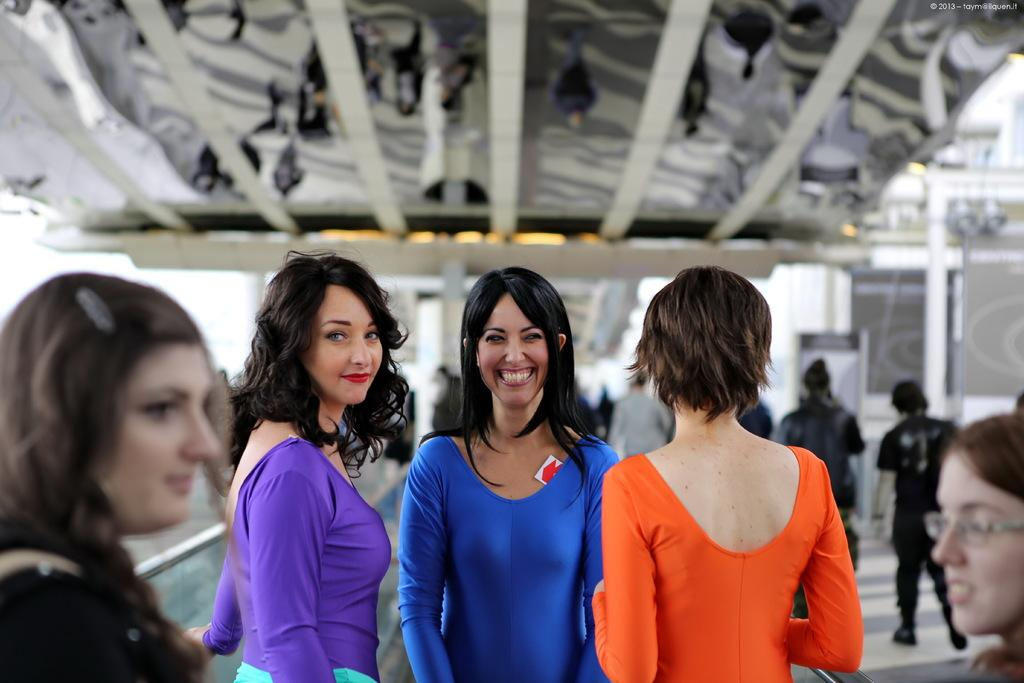What can be seen in the image? There is a group of people in the image. Can you describe the woman in the image? The woman in the image is smiling and wearing a blue dress. What is the background of the image like? The background of the image is blurry. What type of store can be seen in the woman in the image? There is no store present in the image; it features a group of people and a woman. What is the woman's elbow doing in the image? There is no mention of the woman's elbow in the image, as the focus is on her smile and blue dress. 